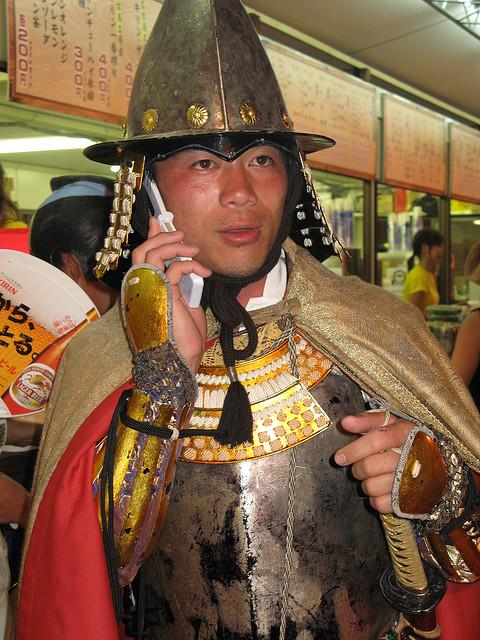Does the cell phone fit with his other attire?
Short answer required. No. Where is the advertisement for beer?
Quick response, please. Left. Which hand is the guy holding the cell phone in?
Keep it brief. Right. 